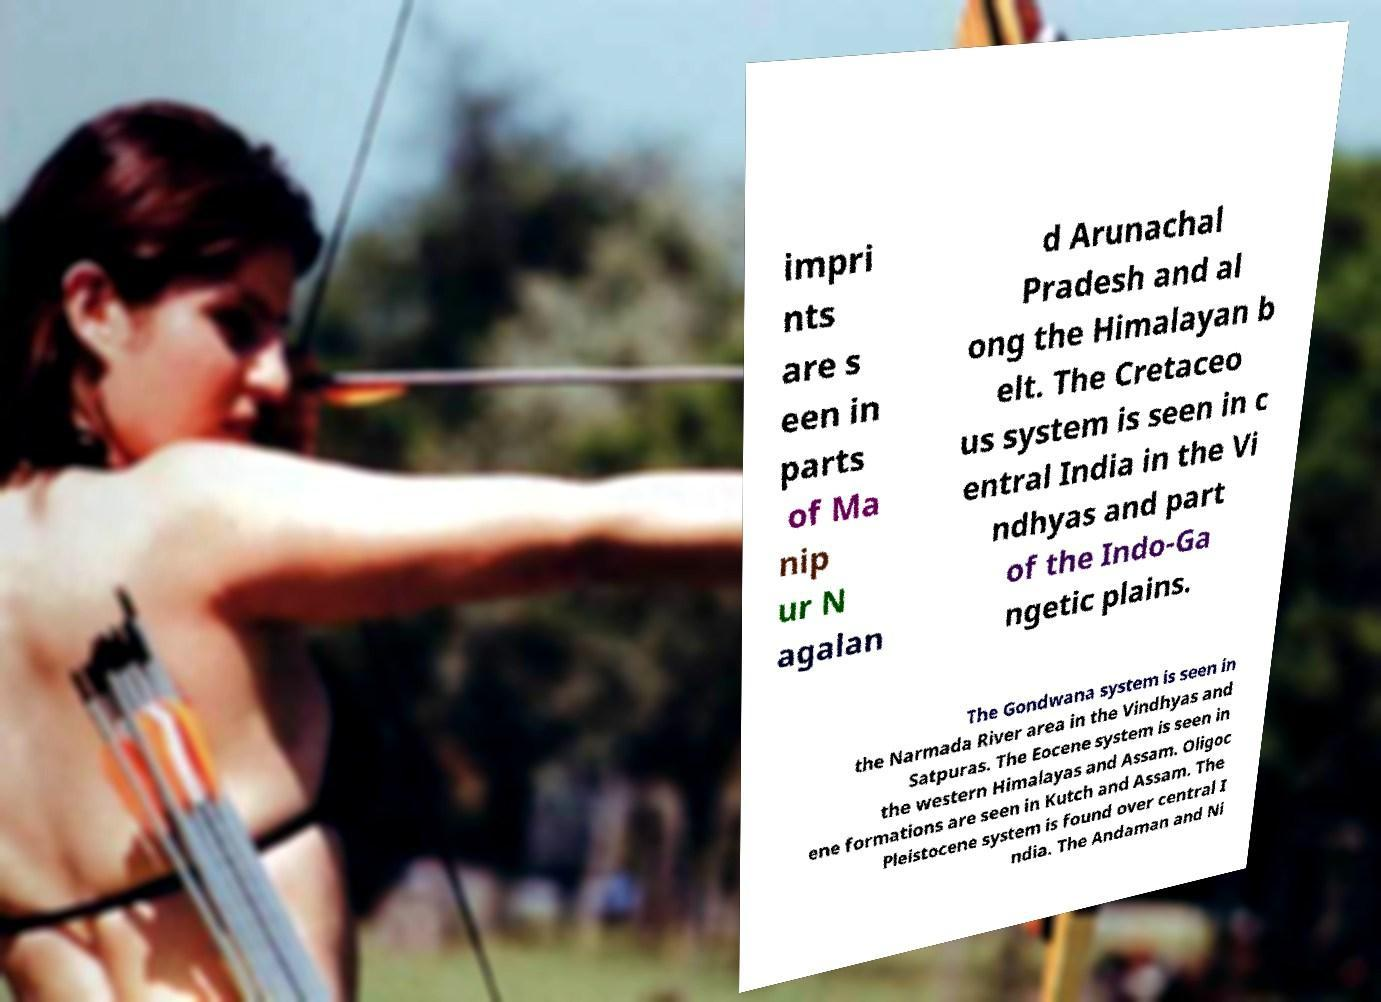Can you read and provide the text displayed in the image?This photo seems to have some interesting text. Can you extract and type it out for me? impri nts are s een in parts of Ma nip ur N agalan d Arunachal Pradesh and al ong the Himalayan b elt. The Cretaceo us system is seen in c entral India in the Vi ndhyas and part of the Indo-Ga ngetic plains. The Gondwana system is seen in the Narmada River area in the Vindhyas and Satpuras. The Eocene system is seen in the western Himalayas and Assam. Oligoc ene formations are seen in Kutch and Assam. The Pleistocene system is found over central I ndia. The Andaman and Ni 